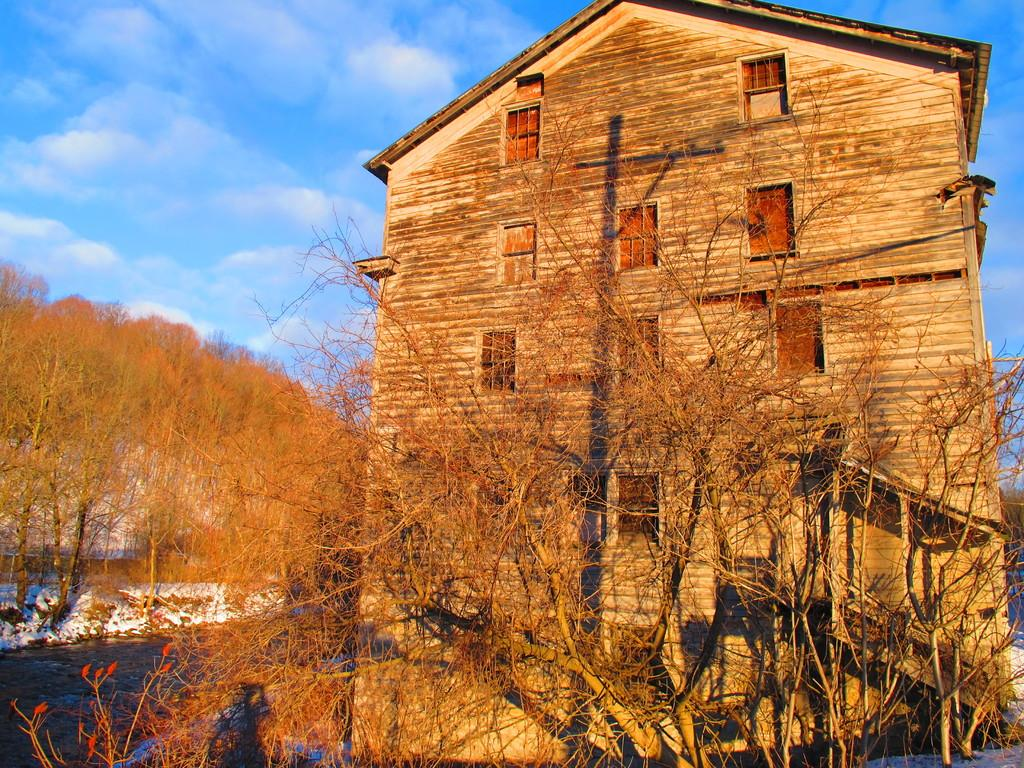What type of vegetation can be seen in the image? There are dried trees in the image. What colorful elements are present in the image? There are red flowers in the image. What type of structure can be seen in the background of the image? There is a wooden house in the background of the image. What is the color of the sky in the image? The sky is blue and white in color. How many sheep are visible in the image? There are no sheep present in the image. What type of growth can be seen on the wooden house in the image? There is no growth visible on the wooden house in the image. 